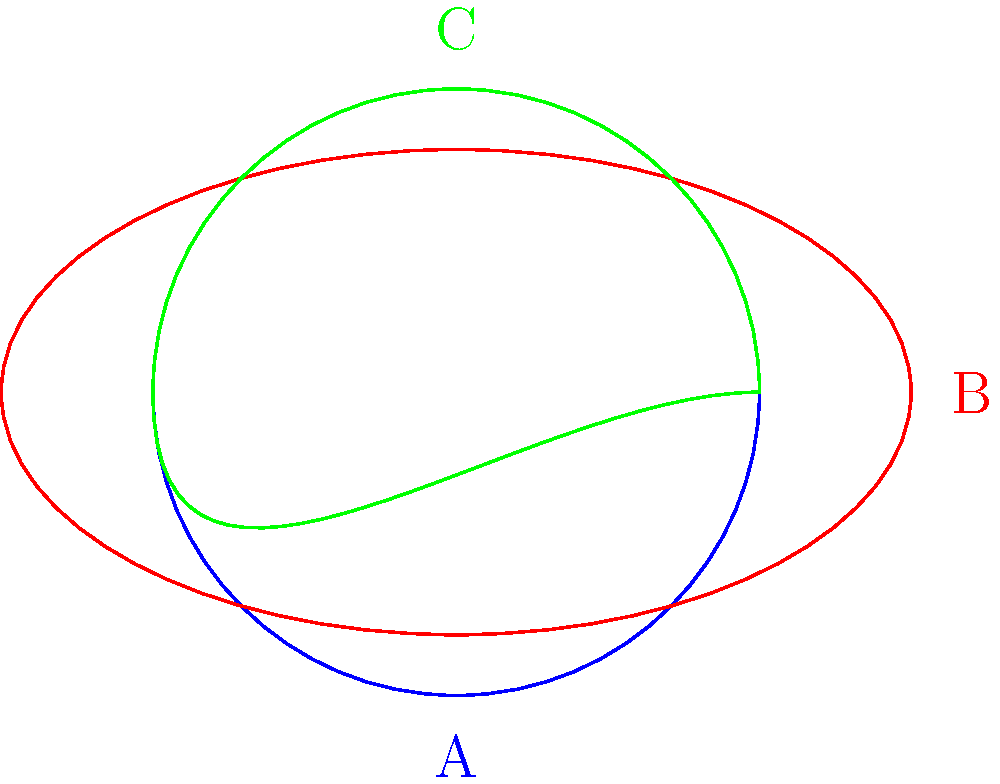In the spirit of Tom Waits' eclectic musical style, consider three closed curves representing vinyl record grooves. Curve A is a perfect circle, curve B is an ellipse, and curve C is a trefoil knot. Which of these curves are homeomorphic to each other? To determine which curves are homeomorphic, we need to consider their topological properties:

1. Curve A (circle):
   - A simple closed curve
   - Can be continuously deformed into any other simple closed curve without breaking or crossing itself

2. Curve B (ellipse):
   - Also a simple closed curve
   - Can be continuously deformed into a circle without breaking or crossing itself

3. Curve C (trefoil knot):
   - A closed curve, but not simple (it crosses itself)
   - Cannot be continuously deformed into a circle or ellipse without breaking or passing through itself

Homeomorphism preserves topological properties. Two objects are homeomorphic if one can be continuously deformed into the other without cutting, tearing, or gluing.

Therefore:
- Curves A and B are homeomorphic to each other, as they are both simple closed curves that can be continuously deformed into one another.
- Curve C is not homeomorphic to either A or B, as it has a fundamentally different structure (knotted) that cannot be undone through continuous deformation.
Answer: A and B are homeomorphic; C is not homeomorphic to A or B. 